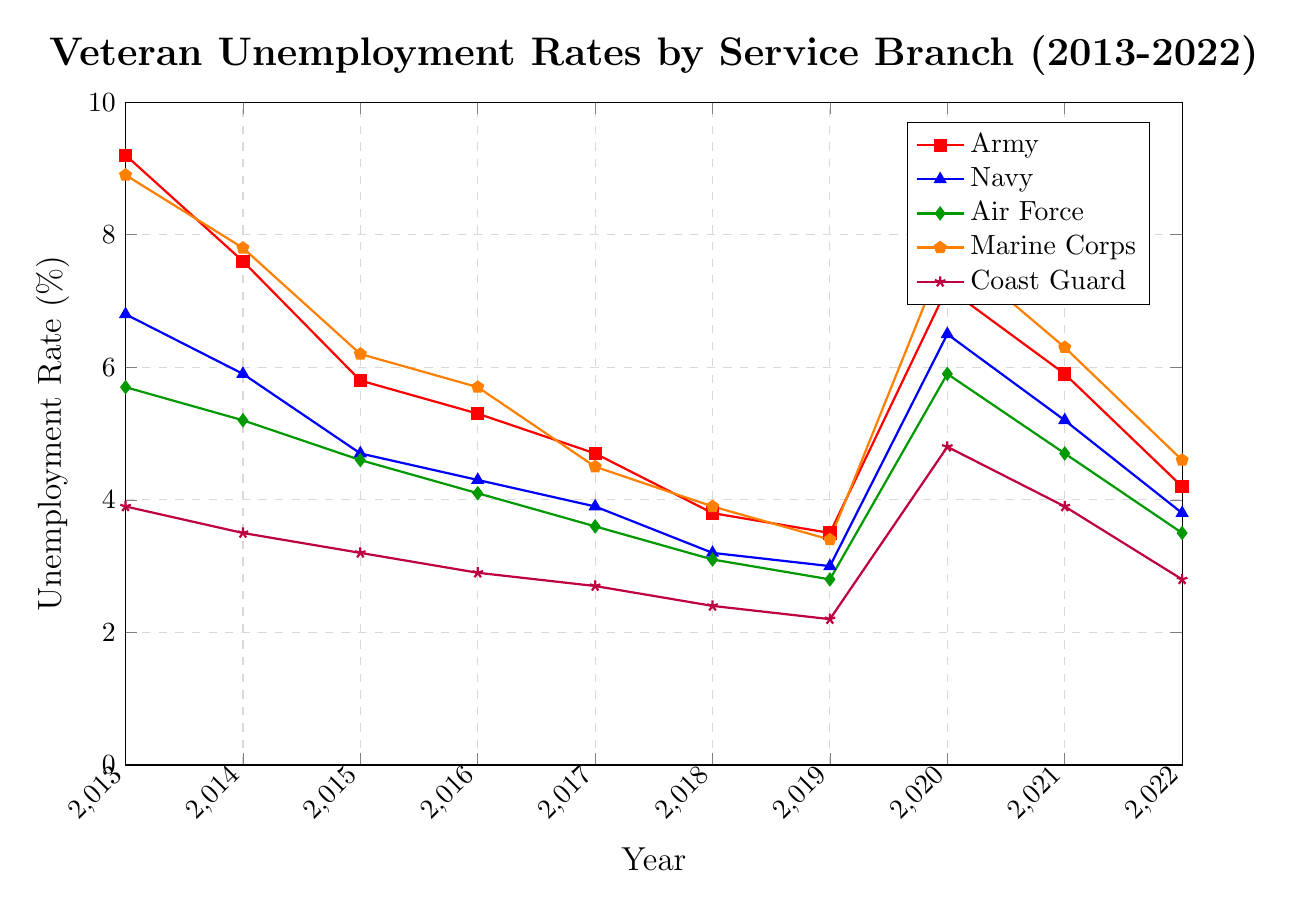Which service branch had the highest unemployment rate in 2013? In 2013, the highest unemployment rate shown in the graph is for the Army at 9.2%.
Answer: Army How did the unemployment rate for the Marine Corps change from 2019 to 2020? The unemployment rate for the Marine Corps increased from 3.4% in 2019 to 7.8% in 2020.
Answer: Increased Was the unemployment rate of the Navy ever higher than the Coast Guard between 2013-2022? By comparing the Navy and Coast Guard rates each year from 2013 to 2022, it is evident that the Navy's unemployment rate was consistently higher than the Coast Guard's.
Answer: Yes In which year was the unemployment rate for the Air Force at its lowest? By examining the data points, the Air Force had its lowest unemployment rate in 2019 at 2.8%.
Answer: 2019 What is the average unemployment rate for the Army between 2018 and 2022? Sum the unemployment rates for the Army from 2018 (3.8%), 2019 (3.5%), 2020 (7.2%), 2021 (5.9%), and 2022 (4.2%), then divide by 5 to get the average: (3.8 + 3.5 + 7.2 + 5.9 + 4.2) / 5 = 4.92%.
Answer: 4.92% By how much did the unemployment rate for the Coast Guard increase from its lowest point before 2020 to its peak in 2020? The lowest point for the Coast Guard before 2020 was in 2019 at 2.2%, and it peaked at 4.8% in 2020. The increase is 4.8% - 2.2% = 2.6%.
Answer: 2.6% What was the unemployment rate trend for the Air Force from 2013 to 2019? The graph shows a consistently decreasing unemployment rate for the Air Force from 5.7% in 2013 to 2.8% in 2019.
Answer: Decreasing Which service branch had the most stable unemployment rate pattern between 2013 and 2022? The Coast Guard showed the most stable and consistently lower unemployment rates with relatively small fluctuations compared to other branches.
Answer: Coast Guard 